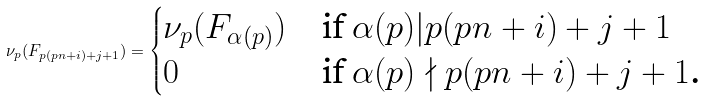<formula> <loc_0><loc_0><loc_500><loc_500>\nu _ { p } ( F _ { p ( p n + i ) + j + 1 } ) = \begin{cases} \nu _ { p } ( F _ { \alpha ( p ) } ) & \text {if $\alpha(p) | p (p n + i) + j + 1$} \\ 0 & \text {if $\alpha(p) \nmid p (p n + i) + j + 1$.} \end{cases}</formula> 